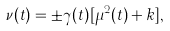<formula> <loc_0><loc_0><loc_500><loc_500>\nu ( t ) = \pm \gamma ( t ) [ \mu ^ { 2 } ( t ) + k ] ,</formula> 